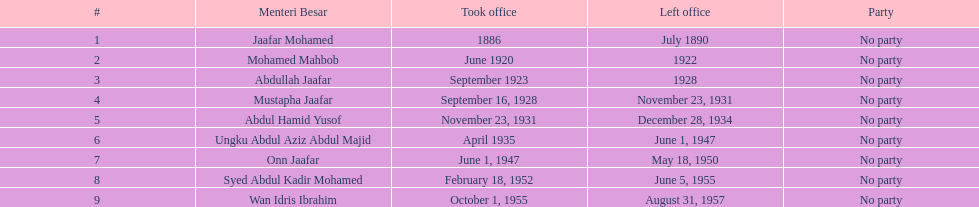Who was the first to take office? Jaafar Mohamed. 